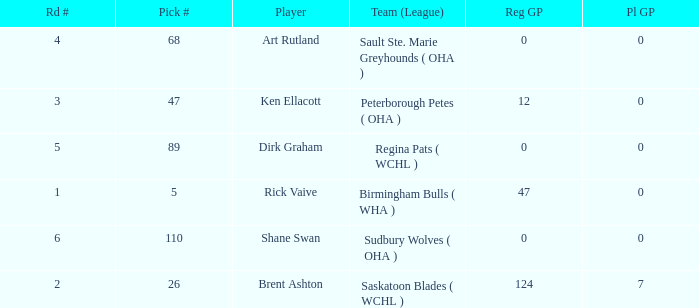How many reg GP for rick vaive in round 1? None. 